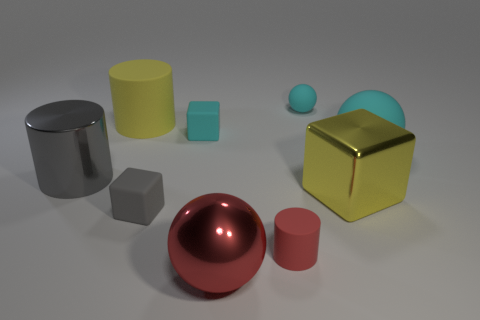What shape is the tiny matte thing that is both to the right of the large red object and behind the gray rubber thing?
Give a very brief answer. Sphere. What number of large cyan balls are the same material as the gray cylinder?
Give a very brief answer. 0. There is a big matte thing that is on the right side of the gray rubber thing; what number of objects are to the left of it?
Give a very brief answer. 8. What is the shape of the big metal thing behind the cube on the right side of the matte ball behind the big cyan rubber object?
Keep it short and to the point. Cylinder. There is a rubber object that is the same color as the metal block; what is its size?
Offer a terse response. Large. How many objects are either purple metal spheres or red matte objects?
Provide a short and direct response. 1. What is the color of the rubber ball that is the same size as the yellow shiny thing?
Ensure brevity in your answer.  Cyan. There is a large yellow rubber thing; does it have the same shape as the red object that is right of the red shiny sphere?
Offer a very short reply. Yes. How many objects are either metal cylinders that are behind the gray matte thing or cyan rubber objects to the left of the large rubber ball?
Provide a short and direct response. 3. There is a rubber object that is the same color as the shiny ball; what is its shape?
Offer a terse response. Cylinder. 